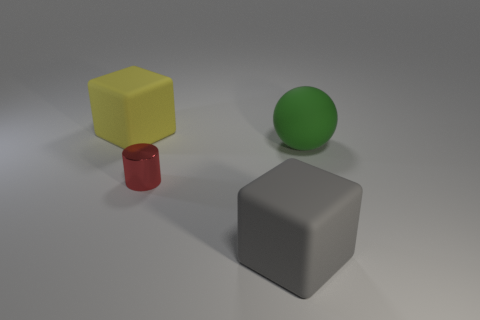Are the yellow cube and the gray cube made of the same material?
Provide a succinct answer. Yes. What size is the other thing that is the same shape as the big yellow rubber thing?
Your response must be concise. Large. There is a large thing that is both behind the large gray matte object and in front of the yellow matte thing; what is its material?
Provide a succinct answer. Rubber. Is the number of matte things right of the big green ball the same as the number of large gray things?
Offer a very short reply. No. What number of things are either large objects that are on the left side of the green rubber sphere or small cylinders?
Keep it short and to the point. 3. There is a rubber block that is left of the shiny object; is it the same color as the cylinder?
Make the answer very short. No. What is the size of the green thing behind the tiny red cylinder?
Make the answer very short. Large. What is the shape of the large rubber thing left of the big rubber block on the right side of the large yellow matte cube?
Provide a short and direct response. Cube. There is another rubber object that is the same shape as the gray rubber object; what is its color?
Provide a succinct answer. Yellow. There is a rubber cube behind the green matte ball; is its size the same as the metal cylinder?
Make the answer very short. No. 